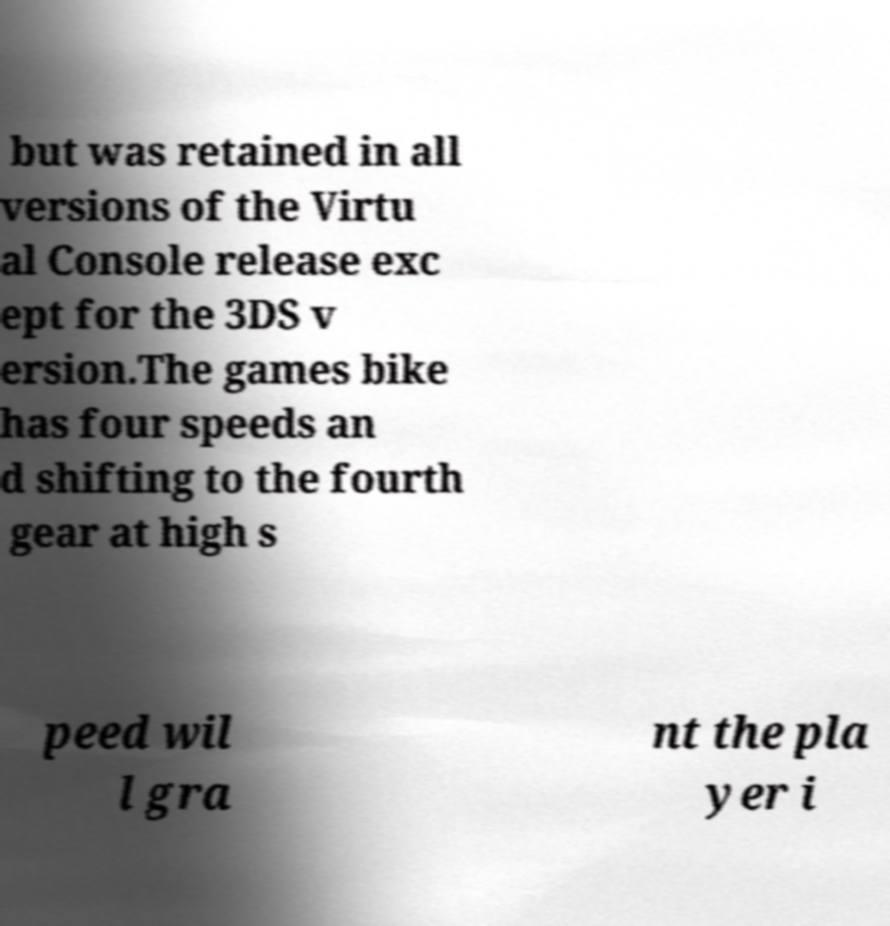Could you assist in decoding the text presented in this image and type it out clearly? but was retained in all versions of the Virtu al Console release exc ept for the 3DS v ersion.The games bike has four speeds an d shifting to the fourth gear at high s peed wil l gra nt the pla yer i 